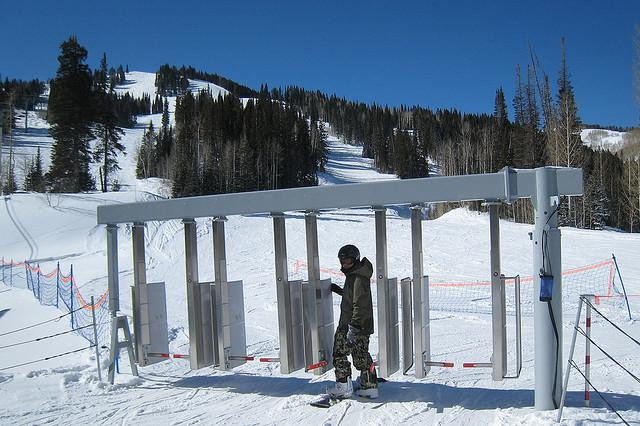What is the skier passing through? gate 